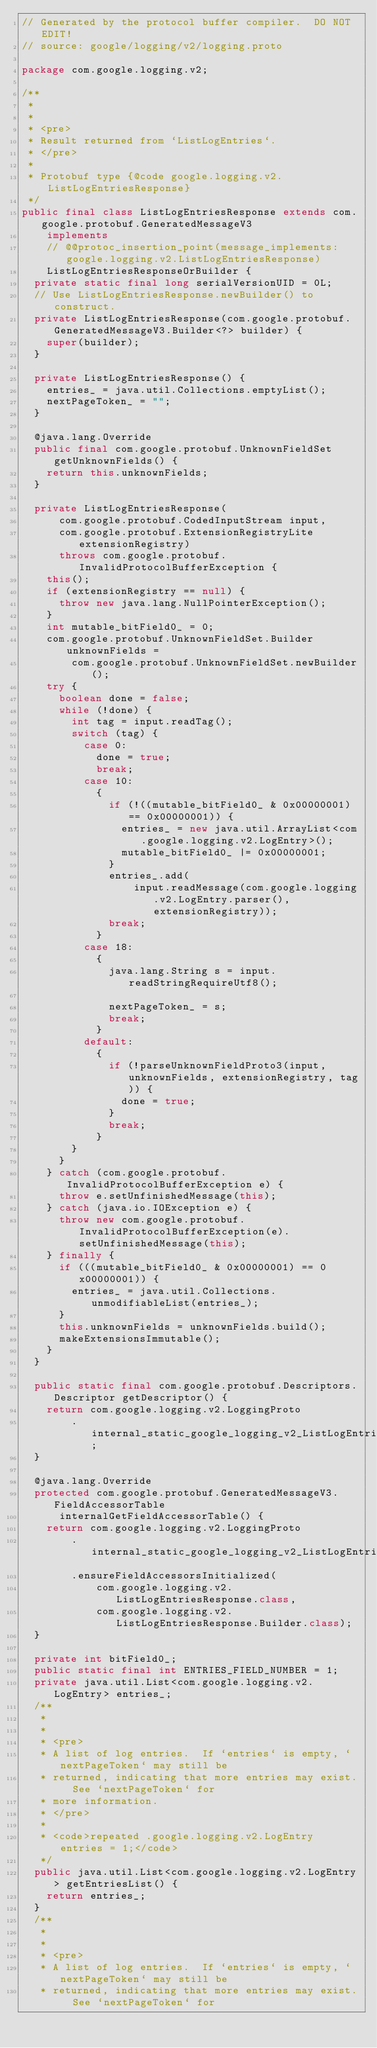Convert code to text. <code><loc_0><loc_0><loc_500><loc_500><_Java_>// Generated by the protocol buffer compiler.  DO NOT EDIT!
// source: google/logging/v2/logging.proto

package com.google.logging.v2;

/**
 *
 *
 * <pre>
 * Result returned from `ListLogEntries`.
 * </pre>
 *
 * Protobuf type {@code google.logging.v2.ListLogEntriesResponse}
 */
public final class ListLogEntriesResponse extends com.google.protobuf.GeneratedMessageV3
    implements
    // @@protoc_insertion_point(message_implements:google.logging.v2.ListLogEntriesResponse)
    ListLogEntriesResponseOrBuilder {
  private static final long serialVersionUID = 0L;
  // Use ListLogEntriesResponse.newBuilder() to construct.
  private ListLogEntriesResponse(com.google.protobuf.GeneratedMessageV3.Builder<?> builder) {
    super(builder);
  }

  private ListLogEntriesResponse() {
    entries_ = java.util.Collections.emptyList();
    nextPageToken_ = "";
  }

  @java.lang.Override
  public final com.google.protobuf.UnknownFieldSet getUnknownFields() {
    return this.unknownFields;
  }

  private ListLogEntriesResponse(
      com.google.protobuf.CodedInputStream input,
      com.google.protobuf.ExtensionRegistryLite extensionRegistry)
      throws com.google.protobuf.InvalidProtocolBufferException {
    this();
    if (extensionRegistry == null) {
      throw new java.lang.NullPointerException();
    }
    int mutable_bitField0_ = 0;
    com.google.protobuf.UnknownFieldSet.Builder unknownFields =
        com.google.protobuf.UnknownFieldSet.newBuilder();
    try {
      boolean done = false;
      while (!done) {
        int tag = input.readTag();
        switch (tag) {
          case 0:
            done = true;
            break;
          case 10:
            {
              if (!((mutable_bitField0_ & 0x00000001) == 0x00000001)) {
                entries_ = new java.util.ArrayList<com.google.logging.v2.LogEntry>();
                mutable_bitField0_ |= 0x00000001;
              }
              entries_.add(
                  input.readMessage(com.google.logging.v2.LogEntry.parser(), extensionRegistry));
              break;
            }
          case 18:
            {
              java.lang.String s = input.readStringRequireUtf8();

              nextPageToken_ = s;
              break;
            }
          default:
            {
              if (!parseUnknownFieldProto3(input, unknownFields, extensionRegistry, tag)) {
                done = true;
              }
              break;
            }
        }
      }
    } catch (com.google.protobuf.InvalidProtocolBufferException e) {
      throw e.setUnfinishedMessage(this);
    } catch (java.io.IOException e) {
      throw new com.google.protobuf.InvalidProtocolBufferException(e).setUnfinishedMessage(this);
    } finally {
      if (((mutable_bitField0_ & 0x00000001) == 0x00000001)) {
        entries_ = java.util.Collections.unmodifiableList(entries_);
      }
      this.unknownFields = unknownFields.build();
      makeExtensionsImmutable();
    }
  }

  public static final com.google.protobuf.Descriptors.Descriptor getDescriptor() {
    return com.google.logging.v2.LoggingProto
        .internal_static_google_logging_v2_ListLogEntriesResponse_descriptor;
  }

  @java.lang.Override
  protected com.google.protobuf.GeneratedMessageV3.FieldAccessorTable
      internalGetFieldAccessorTable() {
    return com.google.logging.v2.LoggingProto
        .internal_static_google_logging_v2_ListLogEntriesResponse_fieldAccessorTable
        .ensureFieldAccessorsInitialized(
            com.google.logging.v2.ListLogEntriesResponse.class,
            com.google.logging.v2.ListLogEntriesResponse.Builder.class);
  }

  private int bitField0_;
  public static final int ENTRIES_FIELD_NUMBER = 1;
  private java.util.List<com.google.logging.v2.LogEntry> entries_;
  /**
   *
   *
   * <pre>
   * A list of log entries.  If `entries` is empty, `nextPageToken` may still be
   * returned, indicating that more entries may exist.  See `nextPageToken` for
   * more information.
   * </pre>
   *
   * <code>repeated .google.logging.v2.LogEntry entries = 1;</code>
   */
  public java.util.List<com.google.logging.v2.LogEntry> getEntriesList() {
    return entries_;
  }
  /**
   *
   *
   * <pre>
   * A list of log entries.  If `entries` is empty, `nextPageToken` may still be
   * returned, indicating that more entries may exist.  See `nextPageToken` for</code> 